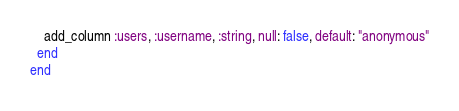Convert code to text. <code><loc_0><loc_0><loc_500><loc_500><_Ruby_>    add_column :users, :username, :string, null: false, default: "anonymous"
  end
end
</code> 